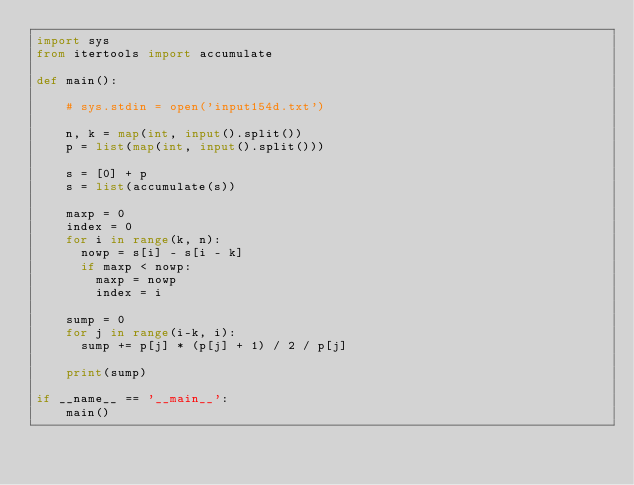Convert code to text. <code><loc_0><loc_0><loc_500><loc_500><_Python_>import sys
from itertools import accumulate

def main():
    
    # sys.stdin = open('input154d.txt')

    n, k = map(int, input().split())
    p = list(map(int, input().split()))
    
    s = [0] + p
    s = list(accumulate(s))

    maxp = 0
    index = 0
    for i in range(k, n):
      nowp = s[i] - s[i - k]
      if maxp < nowp:
        maxp = nowp
        index = i

    sump = 0
    for j in range(i-k, i):
      sump += p[j] * (p[j] + 1) / 2 / p[j]

    print(sump)
        
if __name__ == '__main__':
    main()
</code> 